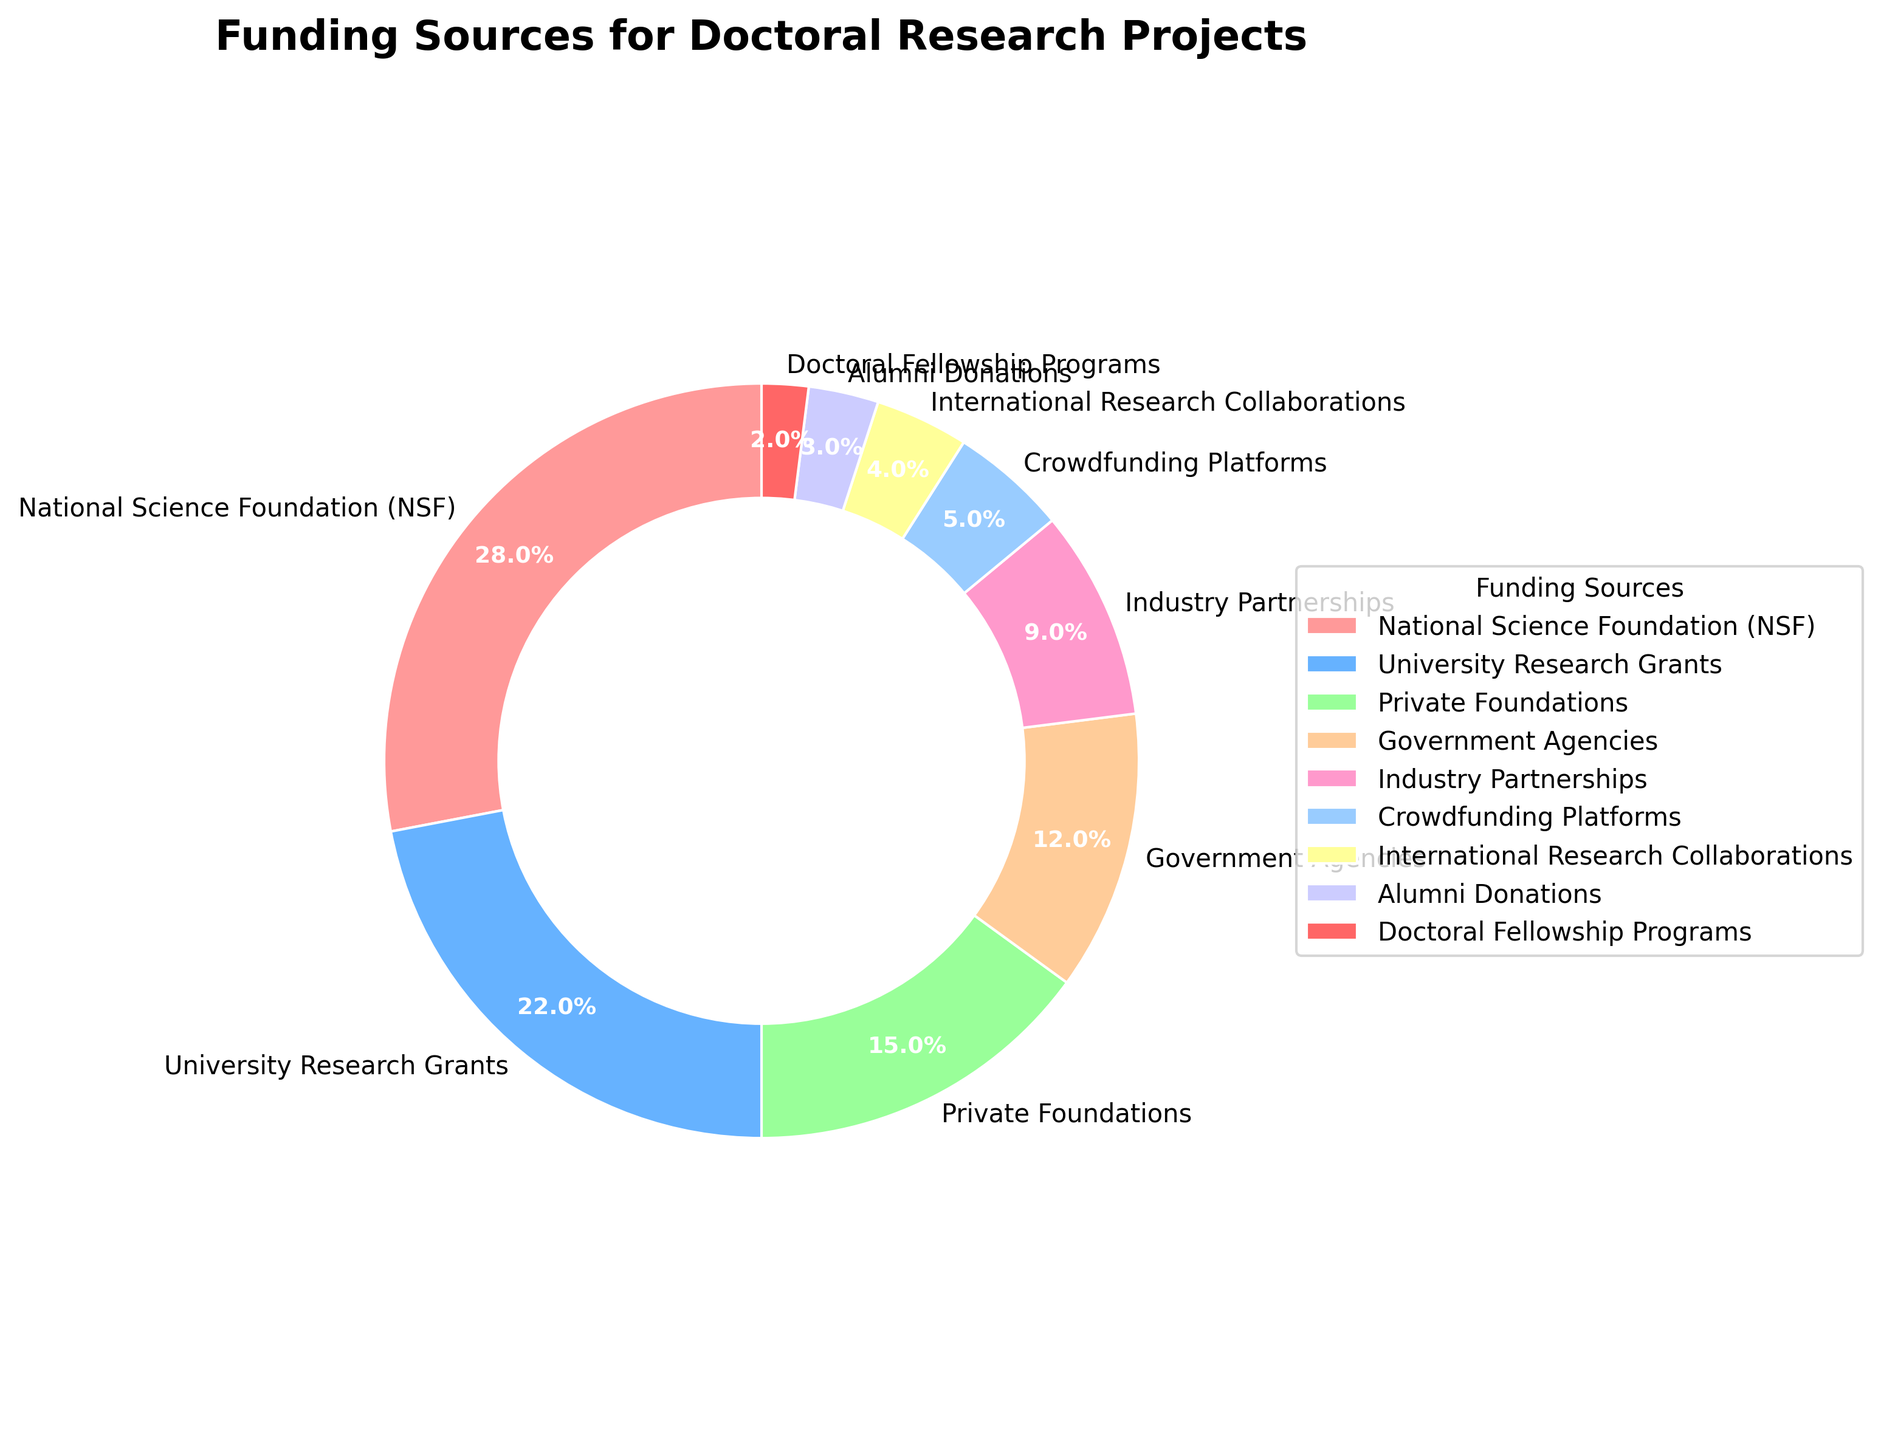What percentage of funding comes from Government Agencies and Industry Partnerships combined? To find the combined percentage, add the individual percentages of Government Agencies (12%) and Industry Partnerships (9%). This results in 12% + 9% = 21%.
Answer: 21% Which funding source has the smallest percentage? Looking at the chart, the funding source with the smallest percentage is Doctoral Fellowship Programs at 2%.
Answer: Doctoral Fellowship Programs Is the funding from National Science Foundation (NSF) greater than the combined funding from Crowdfunding Platforms and International Research Collaborations? The percentage from NSF is 28%. The combined percentage from Crowdfunding Platforms (5%) and International Research Collaborations (4%) is 5% + 4% = 9%. Since 28% is greater than 9%, the funding from NSF is indeed greater.
Answer: Yes Among University Research Grants, Private Foundations, and Industry Partnerships, which has the highest percentage? University Research Grants has 22%, Private Foundations have 15%, and Industry Partnerships have 9%. Thus, University Research Grants have the highest percentage among these three.
Answer: University Research Grants How much more does Alumni Donations contribute compared to Doctoral Fellowship Programs? Alumni Donations contribute 3%, while Doctoral Fellowship Programs contribute 2%. The difference is 3% - 2% = 1%.
Answer: 1% What is the total percentage of funding sources that individually contribute less than 10%? The sources contributing less than 10% are: Industry Partnerships (9%), Crowdfunding Platforms (5%), International Research Collaborations (4%), Alumni Donations (3%), and Doctoral Fellowship Programs (2%). The sum is 9% + 5% + 4% + 3% + 2% = 23%.
Answer: 23% How many funding sources contribute more than 20% each? The sources contributing more than 20% each are National Science Foundation (28%) and University Research Grants (22%). Therefore, there are 2 such sources.
Answer: 2 What is the percentage difference between the highest and lowest funding sources? The highest funding source is National Science Foundation (28%) and the lowest is Doctoral Fellowship Programs (2%). The difference is 28% - 2% = 26%.
Answer: 26% If the funding percentages of Government Agencies and Private Foundations were combined into a single category, where would it rank in terms of size compared to the other sources? Government Agencies contribute 12%, and Private Foundations contribute 15%. Their combined total would be 12% + 15% = 27%. This combined category would be second-largest after National Science Foundation (28%) and ahead of University Research Grants (22%).
Answer: Second-largest Is the percentage of funding from University Research Grants closer to the percentage from Private Foundations or Industry Partnerships? University Research Grants is 22%. Private Foundations is 15%, and Industry Partnerships is 9%. The difference with Private Foundations is 22% - 15% = 7%. The difference with Industry Partnerships is 22% - 9% = 13%. The percentage is closer to Private Foundations.
Answer: Private Foundations 